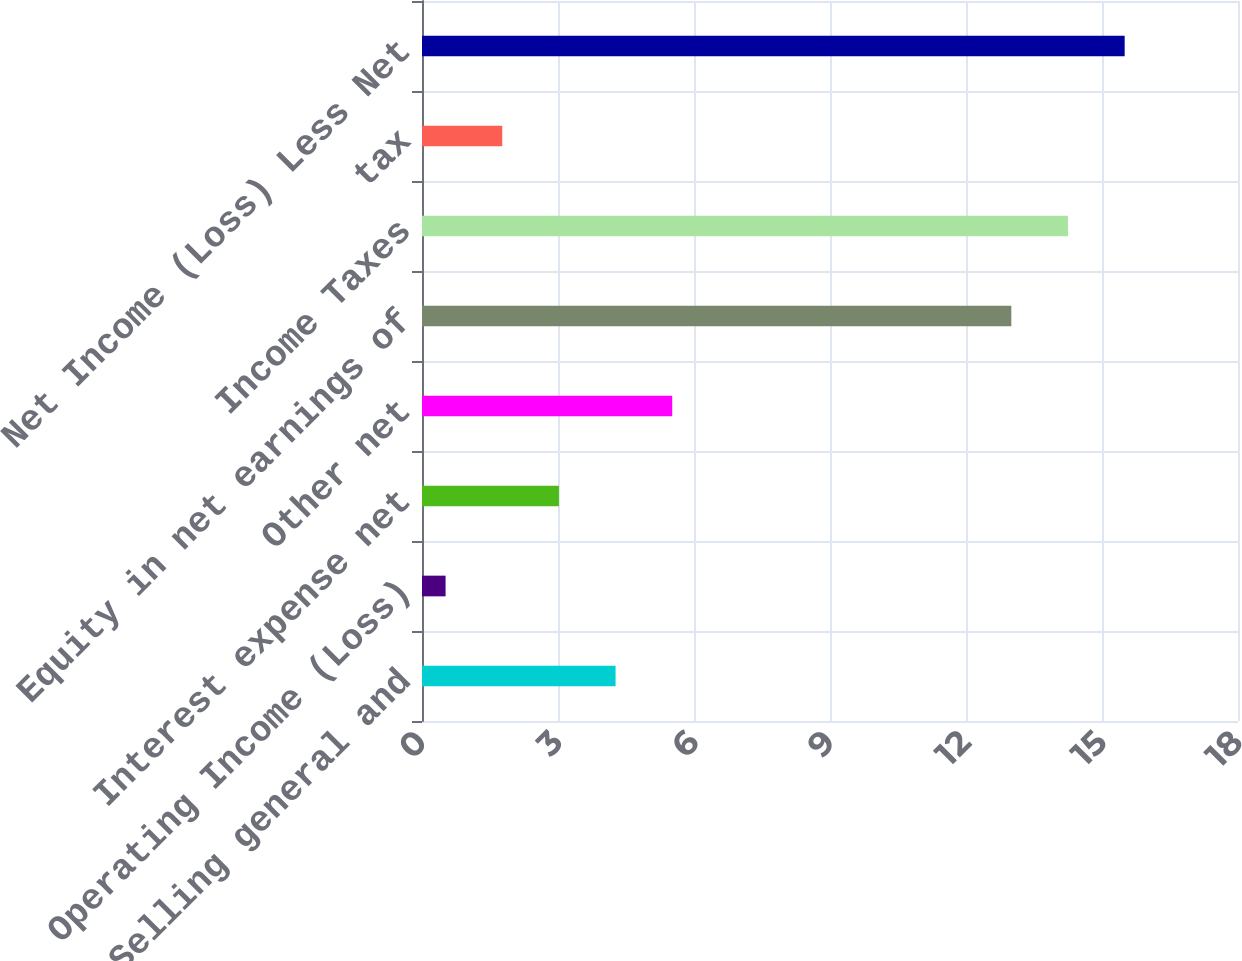Convert chart. <chart><loc_0><loc_0><loc_500><loc_500><bar_chart><fcel>Selling general and<fcel>Operating Income (Loss)<fcel>Interest expense net<fcel>Other net<fcel>Equity in net earnings of<fcel>Income Taxes<fcel>tax<fcel>Net Income (Loss) Less Net<nl><fcel>4.27<fcel>0.52<fcel>3.02<fcel>5.52<fcel>13<fcel>14.25<fcel>1.77<fcel>15.5<nl></chart> 